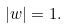<formula> <loc_0><loc_0><loc_500><loc_500>| w | = 1 .</formula> 